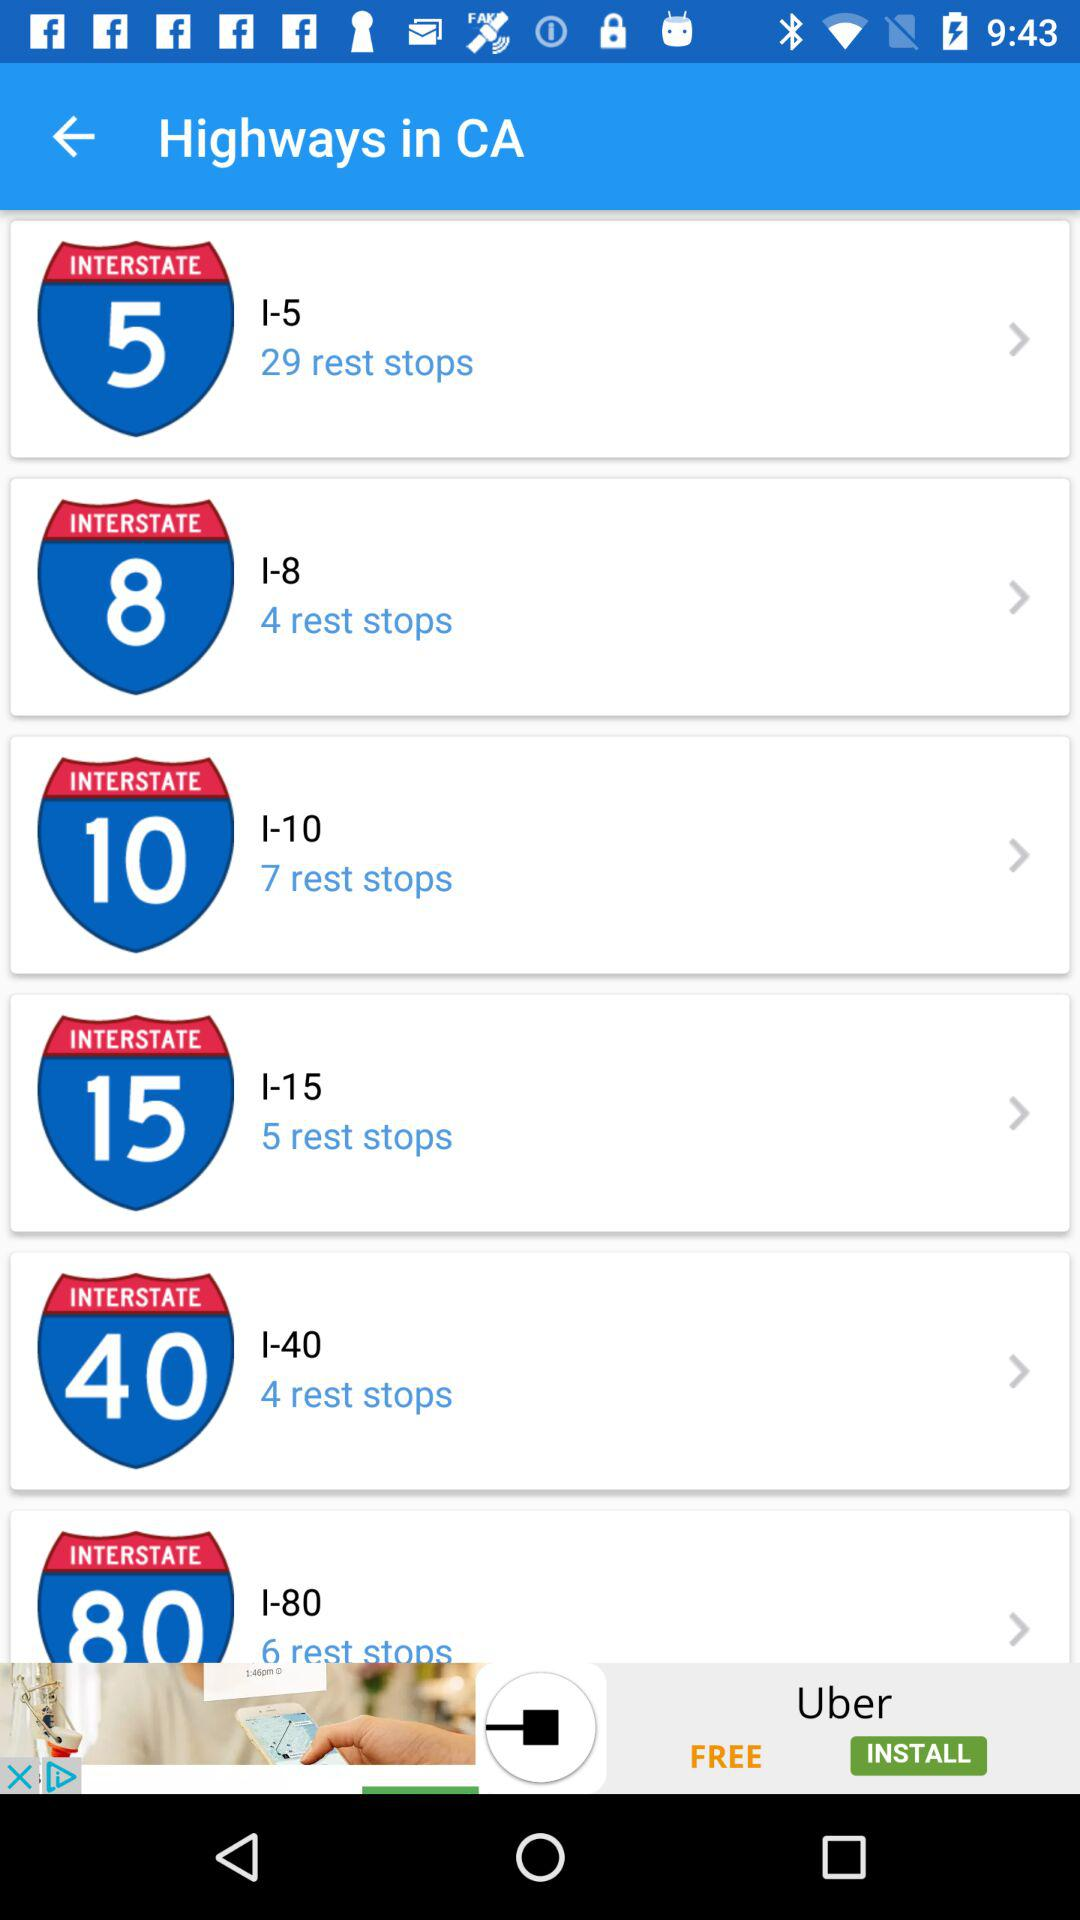What is the number of rest stops in "INTERSTATE 8"? The number of rest stops in "INTERSTATE 8" is 4. 